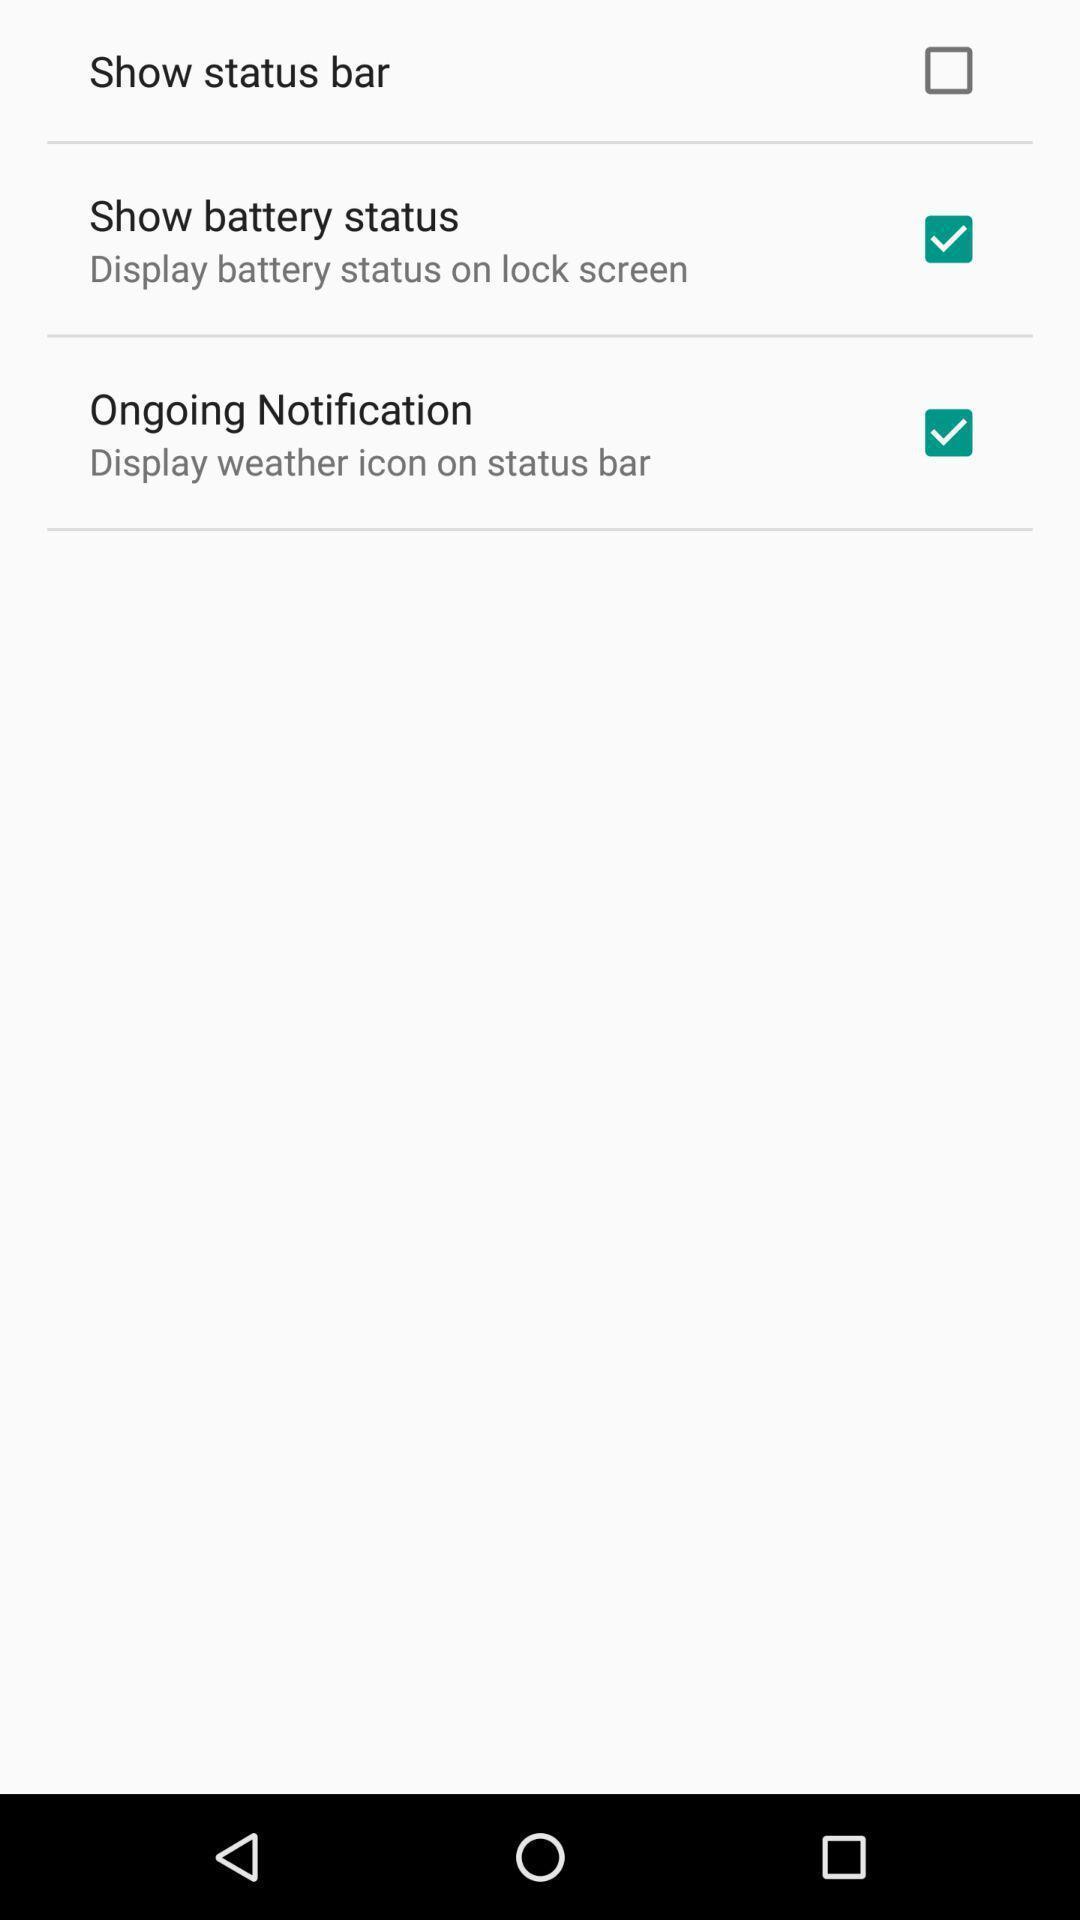Explain what's happening in this screen capture. Page displays options like show status bar. 